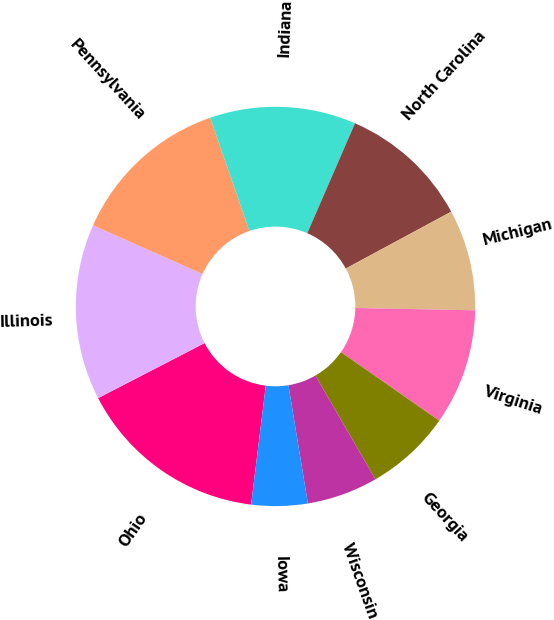Convert chart. <chart><loc_0><loc_0><loc_500><loc_500><pie_chart><fcel>Ohio<fcel>Illinois<fcel>Pennsylvania<fcel>Indiana<fcel>North Carolina<fcel>Michigan<fcel>Virginia<fcel>Georgia<fcel>Wisconsin<fcel>Iowa<nl><fcel>15.46%<fcel>14.25%<fcel>13.04%<fcel>11.82%<fcel>10.61%<fcel>8.18%<fcel>9.39%<fcel>6.96%<fcel>5.75%<fcel>4.54%<nl></chart> 